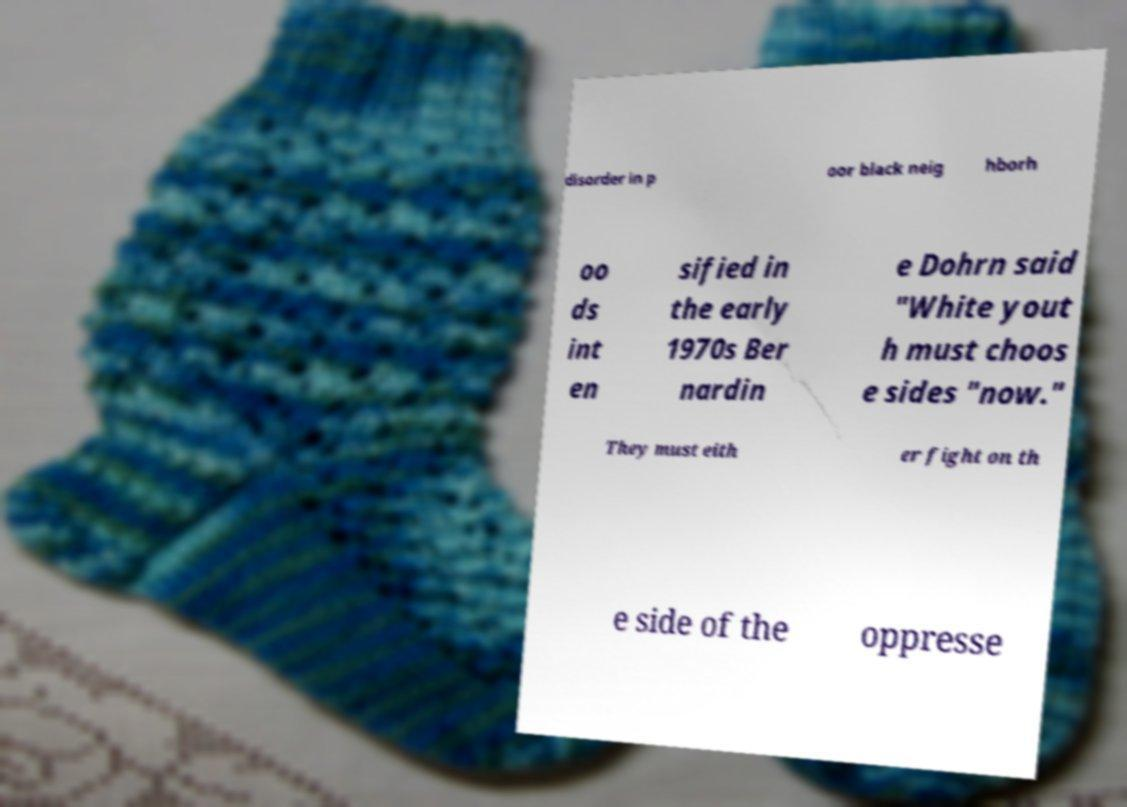Can you read and provide the text displayed in the image?This photo seems to have some interesting text. Can you extract and type it out for me? disorder in p oor black neig hborh oo ds int en sified in the early 1970s Ber nardin e Dohrn said "White yout h must choos e sides "now." They must eith er fight on th e side of the oppresse 